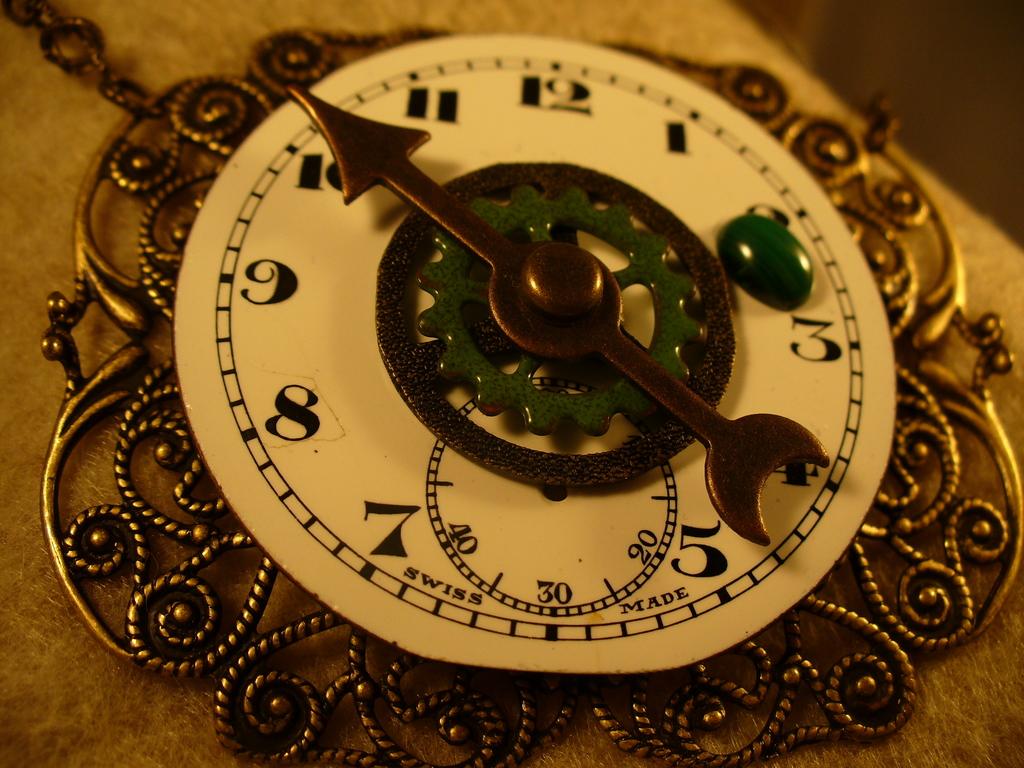It is time is 2.50?
Give a very brief answer. Yes. 